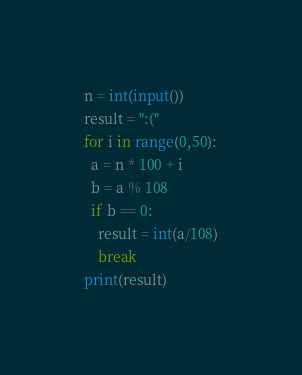<code> <loc_0><loc_0><loc_500><loc_500><_Python_>n = int(input())
result = ":("
for i in range(0,50):
  a = n * 100 + i
  b = a % 108
  if b == 0:
    result = int(a/108)
    break
print(result)</code> 